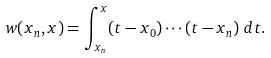<formula> <loc_0><loc_0><loc_500><loc_500>w ( x _ { n } , x ) & = \int _ { x _ { n } } ^ { x } ( t - x _ { 0 } ) \cdots ( t - x _ { n } ) \ d t .</formula> 